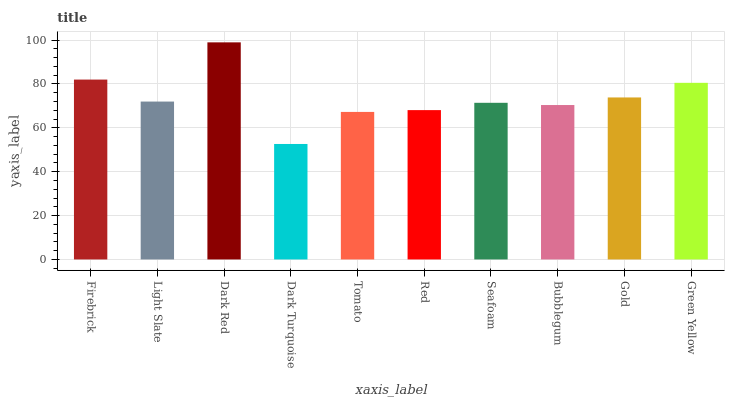Is Dark Turquoise the minimum?
Answer yes or no. Yes. Is Dark Red the maximum?
Answer yes or no. Yes. Is Light Slate the minimum?
Answer yes or no. No. Is Light Slate the maximum?
Answer yes or no. No. Is Firebrick greater than Light Slate?
Answer yes or no. Yes. Is Light Slate less than Firebrick?
Answer yes or no. Yes. Is Light Slate greater than Firebrick?
Answer yes or no. No. Is Firebrick less than Light Slate?
Answer yes or no. No. Is Light Slate the high median?
Answer yes or no. Yes. Is Seafoam the low median?
Answer yes or no. Yes. Is Red the high median?
Answer yes or no. No. Is Dark Turquoise the low median?
Answer yes or no. No. 